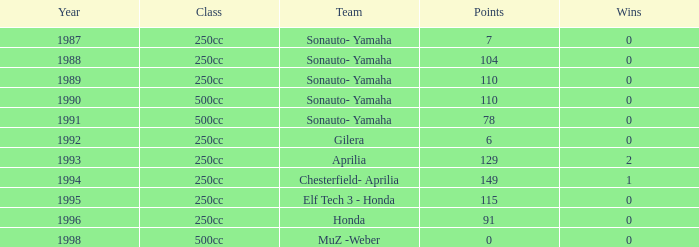What was the highest points tally for a team that had not won any matches before the year 1992? 110.0. Can you parse all the data within this table? {'header': ['Year', 'Class', 'Team', 'Points', 'Wins'], 'rows': [['1987', '250cc', 'Sonauto- Yamaha', '7', '0'], ['1988', '250cc', 'Sonauto- Yamaha', '104', '0'], ['1989', '250cc', 'Sonauto- Yamaha', '110', '0'], ['1990', '500cc', 'Sonauto- Yamaha', '110', '0'], ['1991', '500cc', 'Sonauto- Yamaha', '78', '0'], ['1992', '250cc', 'Gilera', '6', '0'], ['1993', '250cc', 'Aprilia', '129', '2'], ['1994', '250cc', 'Chesterfield- Aprilia', '149', '1'], ['1995', '250cc', 'Elf Tech 3 - Honda', '115', '0'], ['1996', '250cc', 'Honda', '91', '0'], ['1998', '500cc', 'MuZ -Weber', '0', '0']]} 